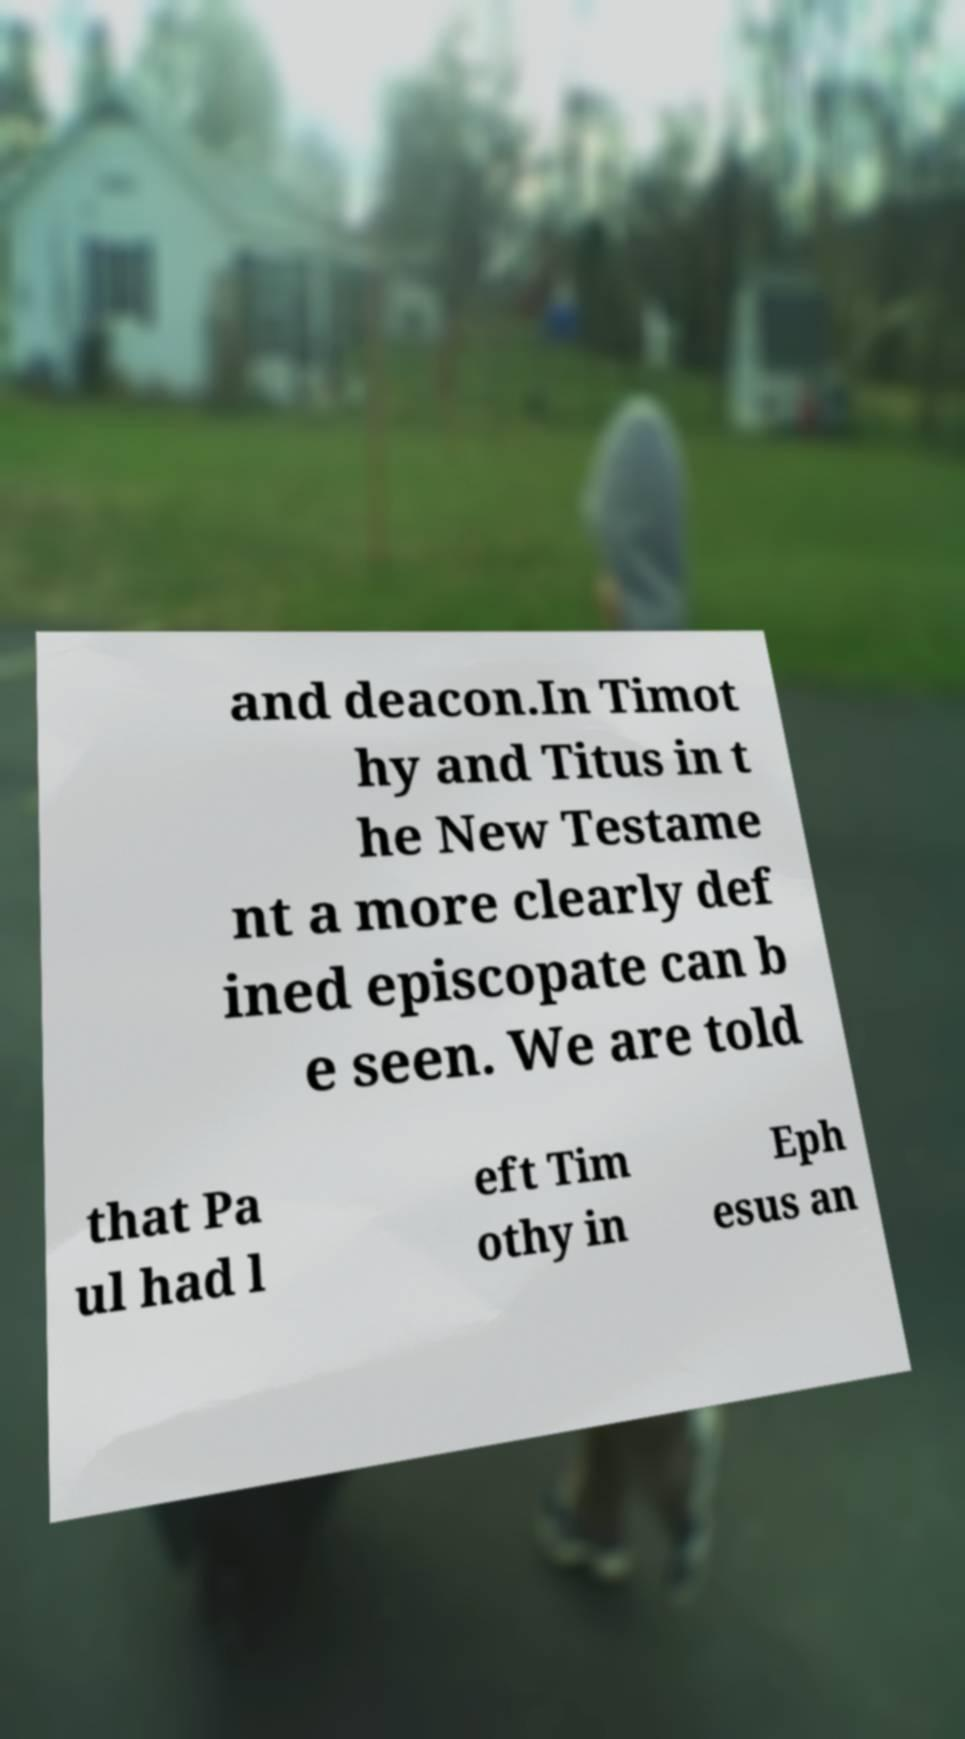Could you extract and type out the text from this image? and deacon.In Timot hy and Titus in t he New Testame nt a more clearly def ined episcopate can b e seen. We are told that Pa ul had l eft Tim othy in Eph esus an 